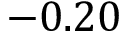Convert formula to latex. <formula><loc_0><loc_0><loc_500><loc_500>- 0 . 2 0</formula> 